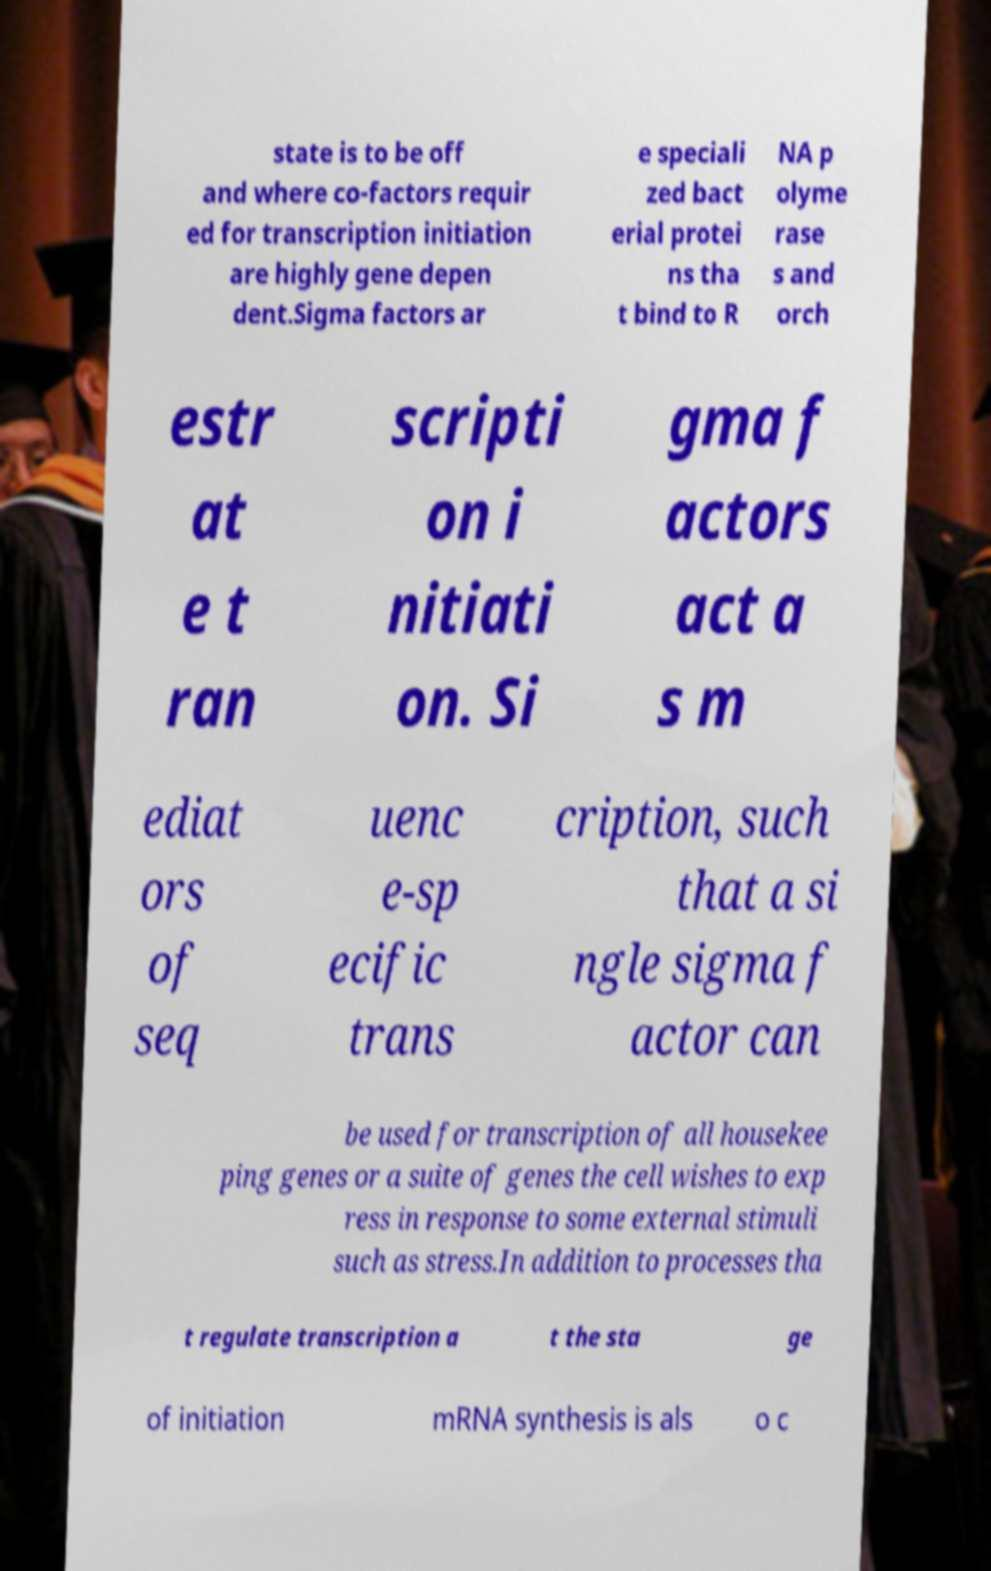There's text embedded in this image that I need extracted. Can you transcribe it verbatim? state is to be off and where co-factors requir ed for transcription initiation are highly gene depen dent.Sigma factors ar e speciali zed bact erial protei ns tha t bind to R NA p olyme rase s and orch estr at e t ran scripti on i nitiati on. Si gma f actors act a s m ediat ors of seq uenc e-sp ecific trans cription, such that a si ngle sigma f actor can be used for transcription of all housekee ping genes or a suite of genes the cell wishes to exp ress in response to some external stimuli such as stress.In addition to processes tha t regulate transcription a t the sta ge of initiation mRNA synthesis is als o c 